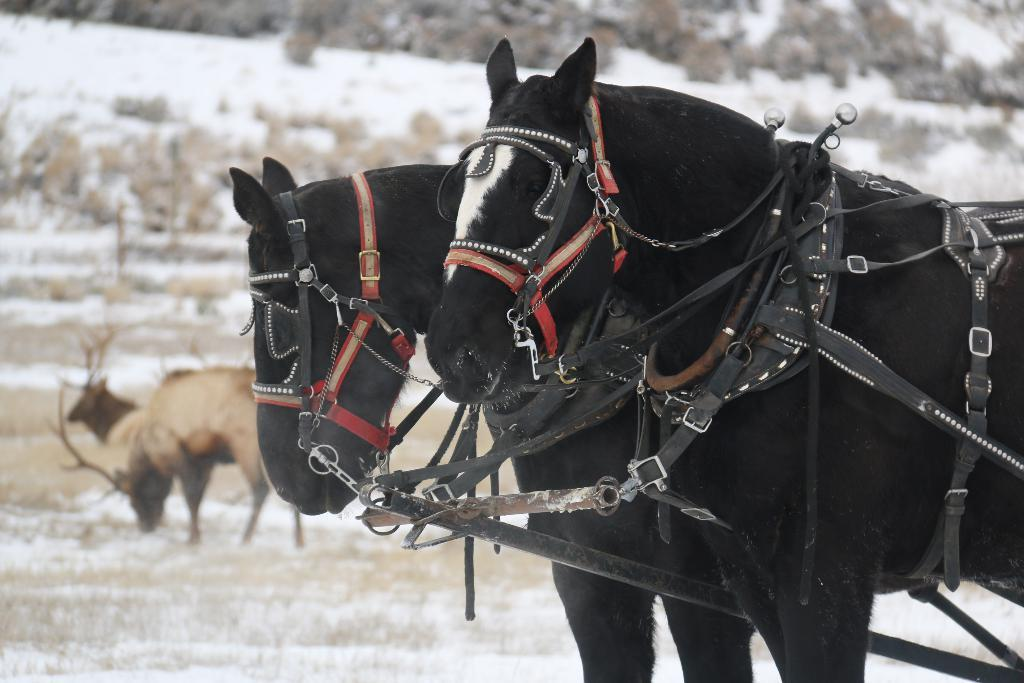What animals are in the center of the image? There are two horses in the center of the image. What is attached to the horses? Belts are attached to the horses. What is the background of the image like? There is snow visible in the background, along with animals and a few other objects. What type of lettuce can be seen growing in the snow in the image? There is no lettuce present in the image; it features two horses with belts attached, snow in the background, and other unspecified objects. 